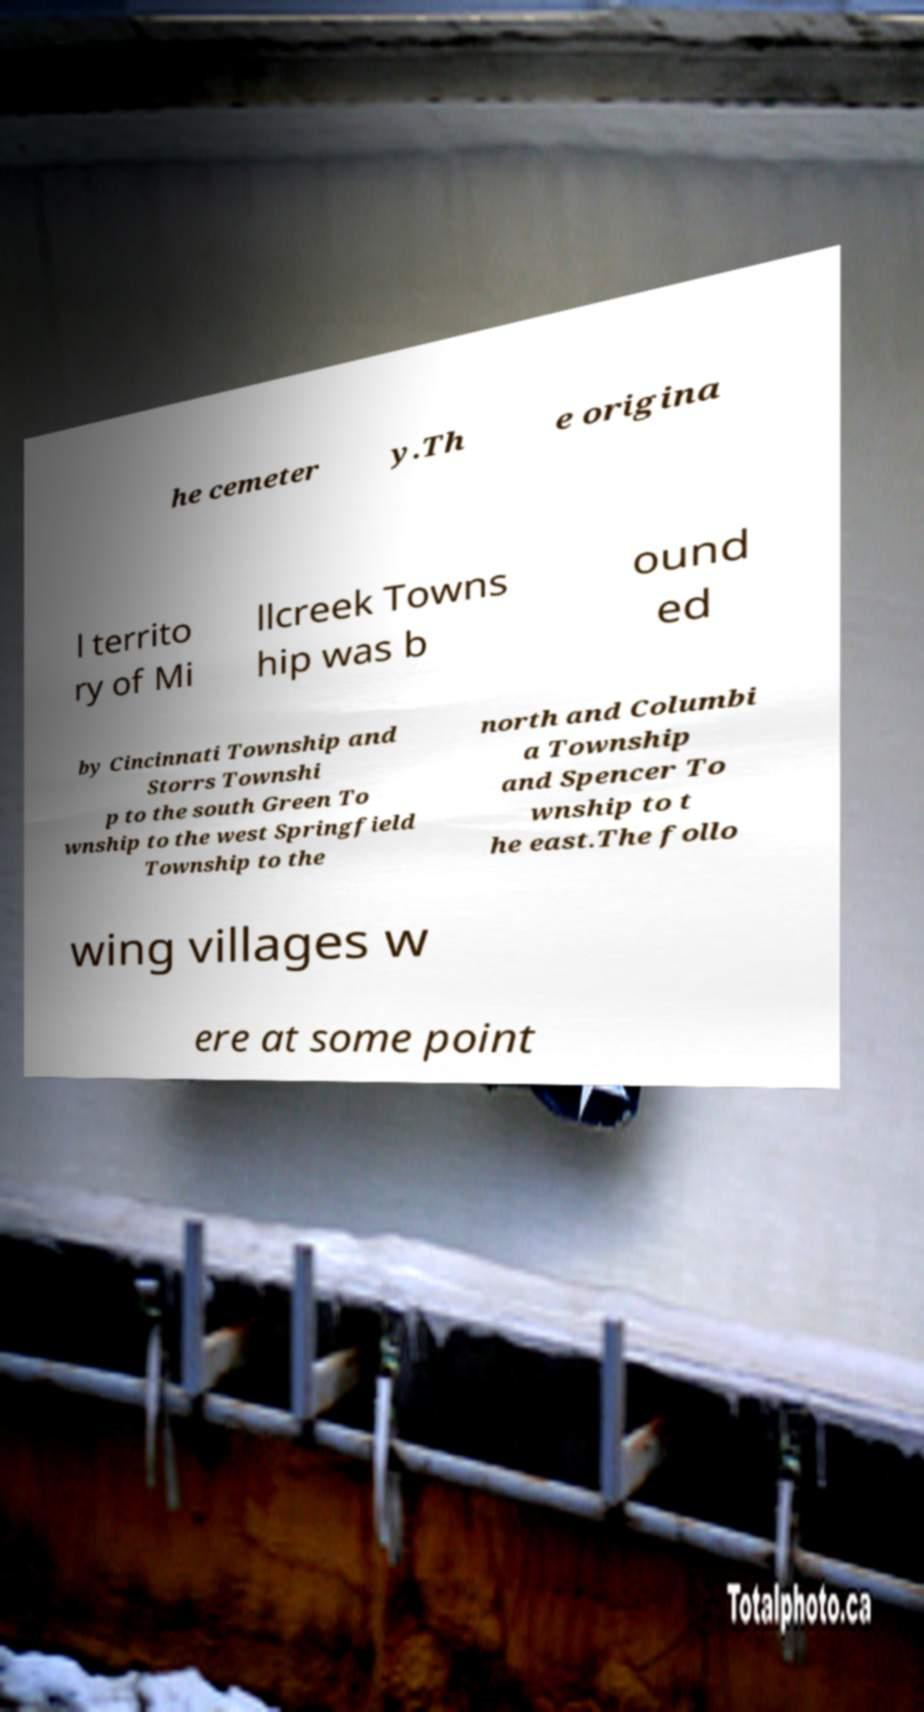Can you accurately transcribe the text from the provided image for me? he cemeter y.Th e origina l territo ry of Mi llcreek Towns hip was b ound ed by Cincinnati Township and Storrs Townshi p to the south Green To wnship to the west Springfield Township to the north and Columbi a Township and Spencer To wnship to t he east.The follo wing villages w ere at some point 